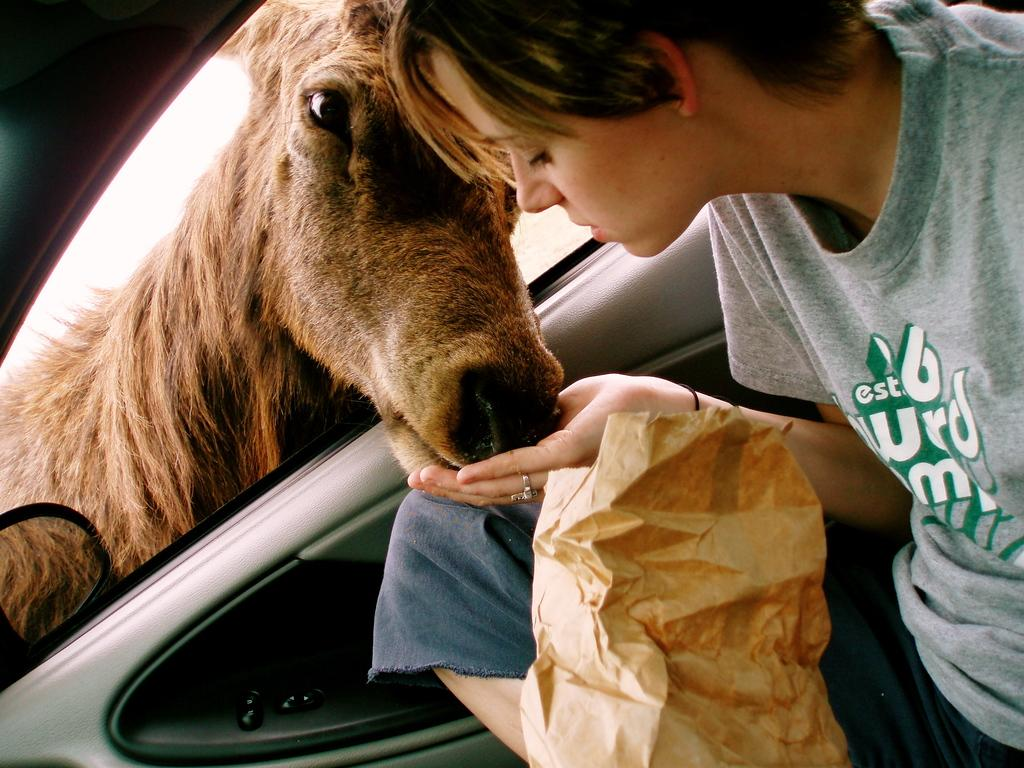Who is present in the image? There is a girl in the image. What is the girl doing in the image? The girl is sitting in a car and feeding a horse. What type of bridge can be seen in the image? There is no bridge present in the image. How does the zebra react to the girl feeding the horse in the image? There is no zebra present in the image, so it cannot react to the girl feeding the horse. 